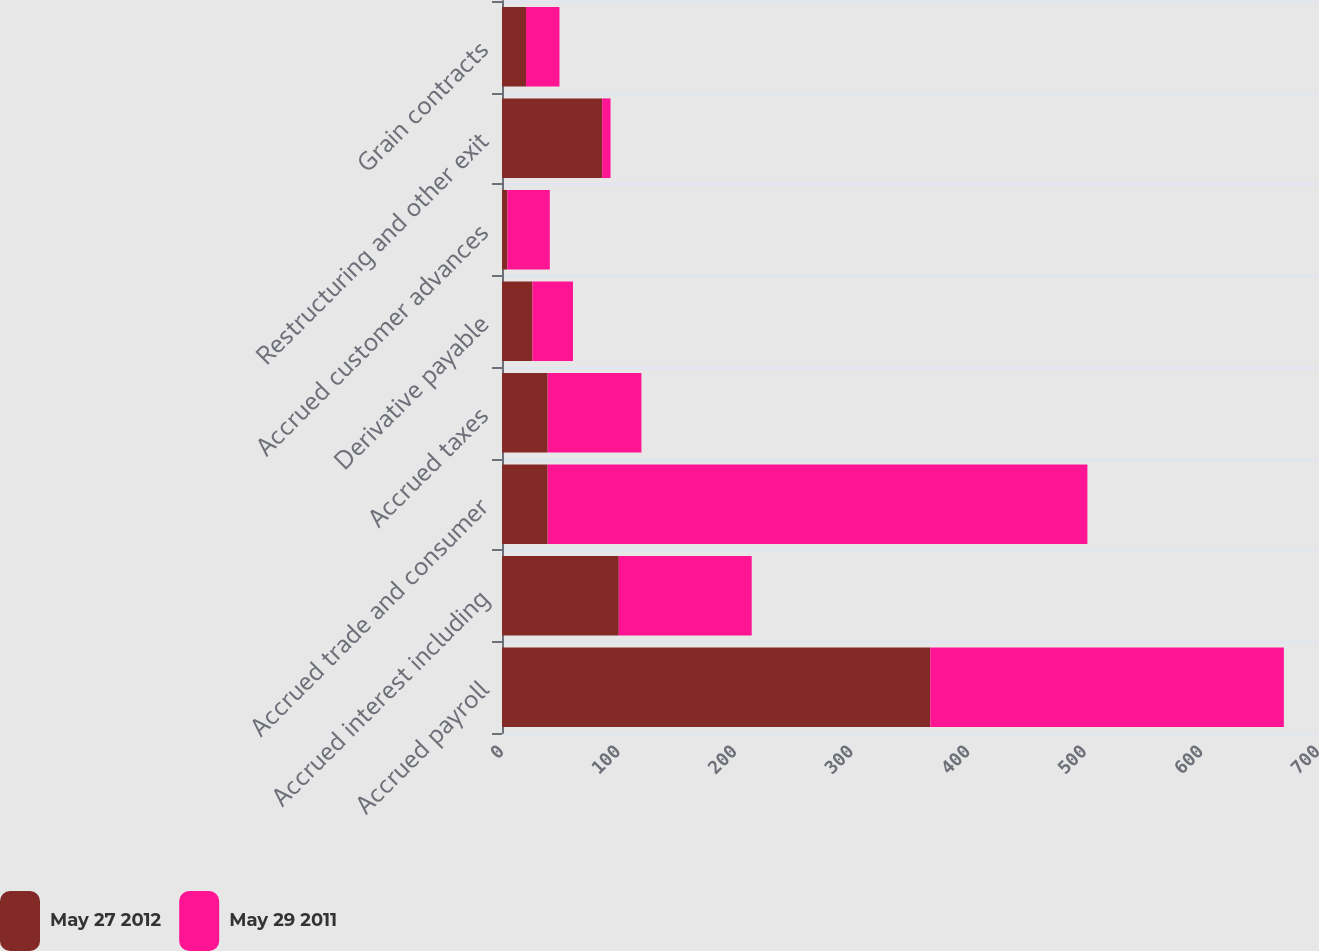Convert chart. <chart><loc_0><loc_0><loc_500><loc_500><stacked_bar_chart><ecel><fcel>Accrued payroll<fcel>Accrued interest including<fcel>Accrued trade and consumer<fcel>Accrued taxes<fcel>Derivative payable<fcel>Accrued customer advances<fcel>Restructuring and other exit<fcel>Grain contracts<nl><fcel>May 27 2012<fcel>367.4<fcel>100.2<fcel>39.2<fcel>39.2<fcel>26.1<fcel>4.6<fcel>85.9<fcel>20.6<nl><fcel>May 29 2011<fcel>303.3<fcel>114<fcel>463<fcel>80.4<fcel>34.8<fcel>36.4<fcel>7.2<fcel>28.7<nl></chart> 